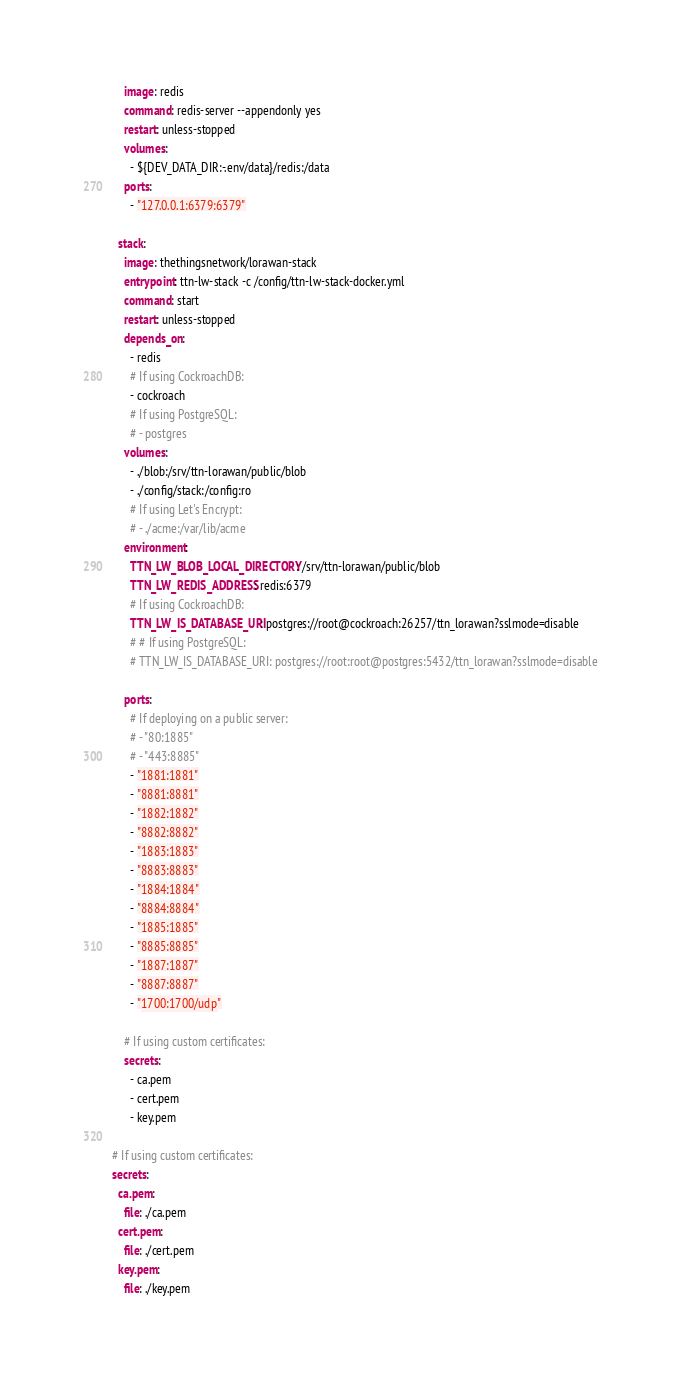Convert code to text. <code><loc_0><loc_0><loc_500><loc_500><_YAML_>    image: redis
    command: redis-server --appendonly yes
    restart: unless-stopped
    volumes:
      - ${DEV_DATA_DIR:-.env/data}/redis:/data
    ports:
      - "127.0.0.1:6379:6379"

  stack:
    image: thethingsnetwork/lorawan-stack
    entrypoint: ttn-lw-stack -c /config/ttn-lw-stack-docker.yml
    command: start
    restart: unless-stopped
    depends_on:
      - redis
      # If using CockroachDB:
      - cockroach
      # If using PostgreSQL:
      # - postgres
    volumes:
      - ./blob:/srv/ttn-lorawan/public/blob
      - ./config/stack:/config:ro
      # If using Let's Encrypt:
      # - ./acme:/var/lib/acme
    environment:
      TTN_LW_BLOB_LOCAL_DIRECTORY: /srv/ttn-lorawan/public/blob
      TTN_LW_REDIS_ADDRESS: redis:6379
      # If using CockroachDB:
      TTN_LW_IS_DATABASE_URI: postgres://root@cockroach:26257/ttn_lorawan?sslmode=disable
      # # If using PostgreSQL:
      # TTN_LW_IS_DATABASE_URI: postgres://root:root@postgres:5432/ttn_lorawan?sslmode=disable

    ports:
      # If deploying on a public server:
      # - "80:1885"
      # - "443:8885"
      - "1881:1881"
      - "8881:8881"
      - "1882:1882"
      - "8882:8882"
      - "1883:1883"
      - "8883:8883"
      - "1884:1884"
      - "8884:8884"
      - "1885:1885"
      - "8885:8885"
      - "1887:1887"
      - "8887:8887"
      - "1700:1700/udp"

    # If using custom certificates:
    secrets:
      - ca.pem
      - cert.pem
      - key.pem

# If using custom certificates:
secrets:
  ca.pem:
    file: ./ca.pem
  cert.pem:
    file: ./cert.pem
  key.pem:
    file: ./key.pem
</code> 